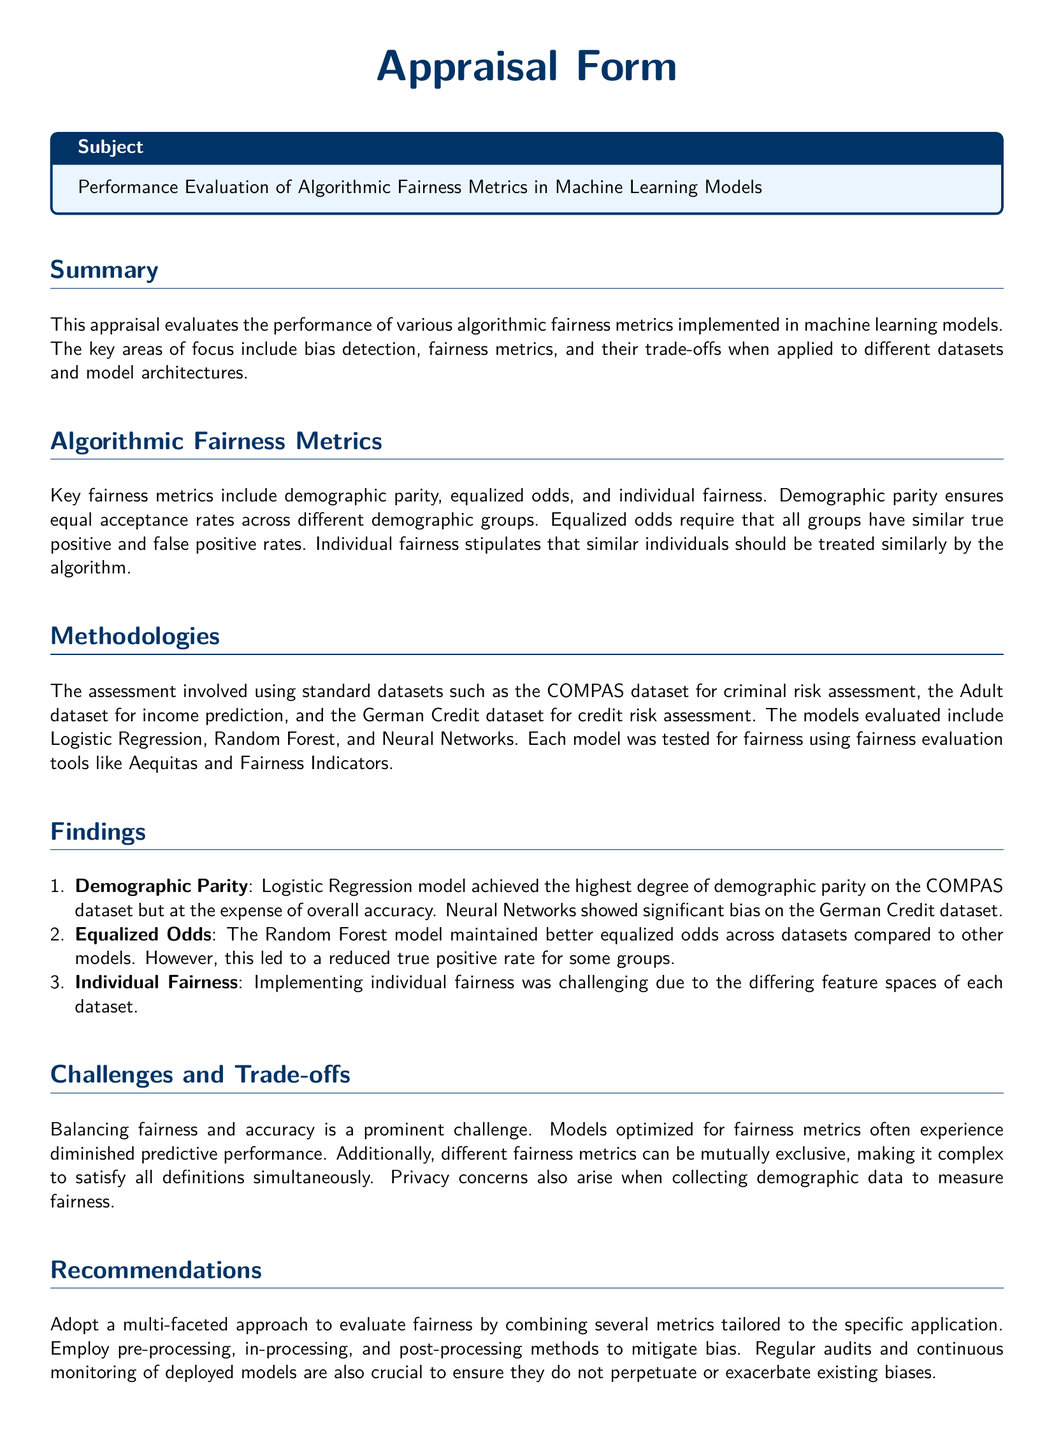What is the main focus of the appraisal? The appraisal focuses on evaluating the performance of algorithmic fairness metrics in machine learning models.
Answer: Algorithmic fairness metrics What datasets were used in the assessment? The datasets used include COMPAS, Adult, and German Credit datasets, as mentioned in the methodologies section.
Answer: COMPAS, Adult, German Credit Which model achieved the highest degree of demographic parity? The Logistic Regression model achieved the highest degree of demographic parity on the COMPAS dataset.
Answer: Logistic Regression What challenge is prominently noted regarding fairness and accuracy? The appraisal highlights that balancing fairness and accuracy is a significant challenge.
Answer: Balancing fairness and accuracy What does individual fairness require? Individual fairness stipulates that similar individuals should be treated similarly by the algorithm.
Answer: Similar treatment for similar individuals Which model maintained better equalized odds across datasets? The Random Forest model maintained better equalized odds compared to other models.
Answer: Random Forest What do the recommendations suggest for evaluating fairness? The recommendations suggest a multi-faceted approach to evaluate fairness by combining several metrics.
Answer: Multi-faceted approach What issue arises from different fairness metrics being mutually exclusive? It creates complexity in satisfying all definitions of fairness simultaneously.
Answer: Complexity in satisfying all definitions 